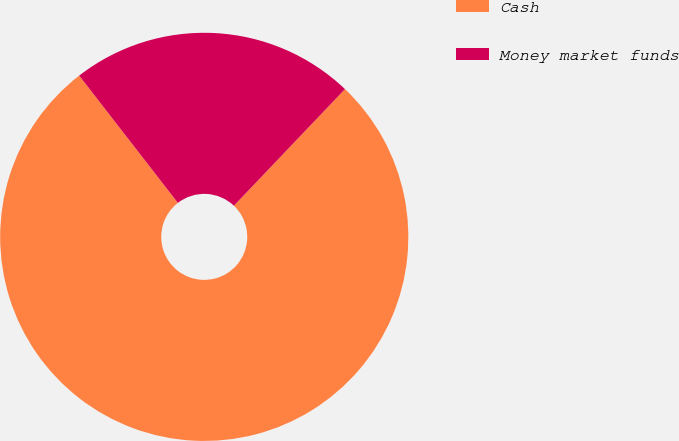<chart> <loc_0><loc_0><loc_500><loc_500><pie_chart><fcel>Cash<fcel>Money market funds<nl><fcel>77.39%<fcel>22.61%<nl></chart> 